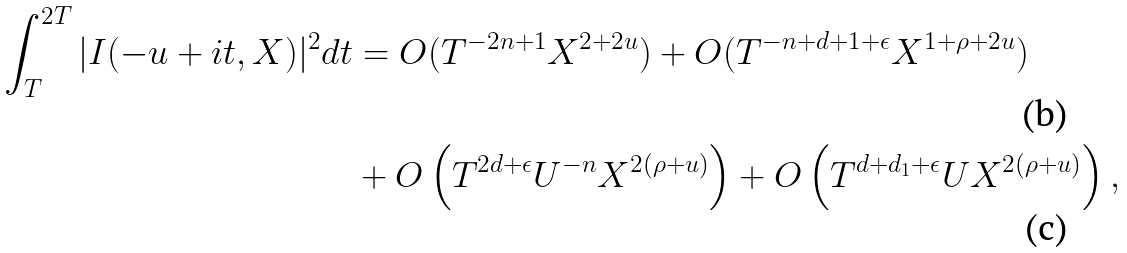Convert formula to latex. <formula><loc_0><loc_0><loc_500><loc_500>\int _ { T } ^ { 2 T } | I ( - u + i t , X ) | ^ { 2 } d t & = O ( T ^ { - 2 n + 1 } X ^ { 2 + 2 u } ) + O ( T ^ { - n + d + 1 + \epsilon } X ^ { 1 + \rho + 2 u } ) \\ & + O \left ( T ^ { 2 d + \epsilon } U ^ { - n } X ^ { 2 ( \rho + u ) } \right ) + O \left ( T ^ { d + d _ { 1 } + \epsilon } U X ^ { 2 ( \rho + u ) } \right ) ,</formula> 